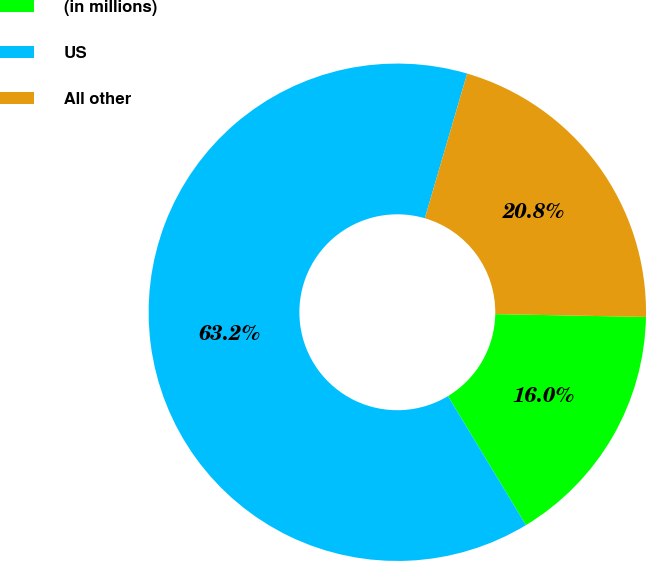<chart> <loc_0><loc_0><loc_500><loc_500><pie_chart><fcel>(in millions)<fcel>US<fcel>All other<nl><fcel>16.05%<fcel>63.18%<fcel>20.77%<nl></chart> 